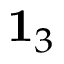<formula> <loc_0><loc_0><loc_500><loc_500>{ 1 } _ { 3 }</formula> 